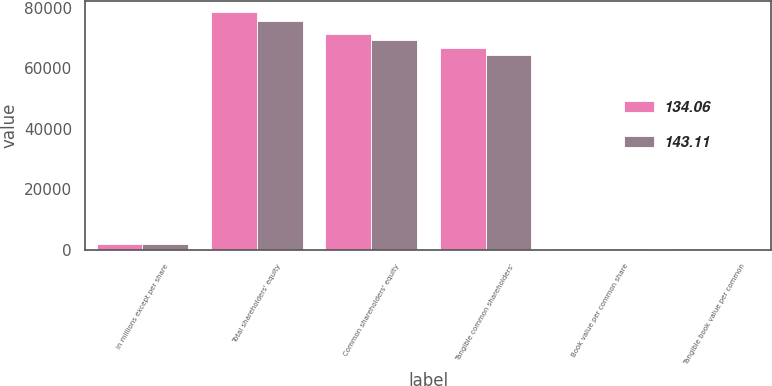Convert chart. <chart><loc_0><loc_0><loc_500><loc_500><stacked_bar_chart><ecel><fcel>in millions except per share<fcel>Total shareholders' equity<fcel>Common shareholders' equity<fcel>Tangible common shareholders'<fcel>Book value per common share<fcel>Tangible book value per common<nl><fcel>134.06<fcel>2013<fcel>78467<fcel>71267<fcel>66891<fcel>152.48<fcel>143.11<nl><fcel>143.11<fcel>2012<fcel>75716<fcel>69516<fcel>64417<fcel>144.67<fcel>134.06<nl></chart> 